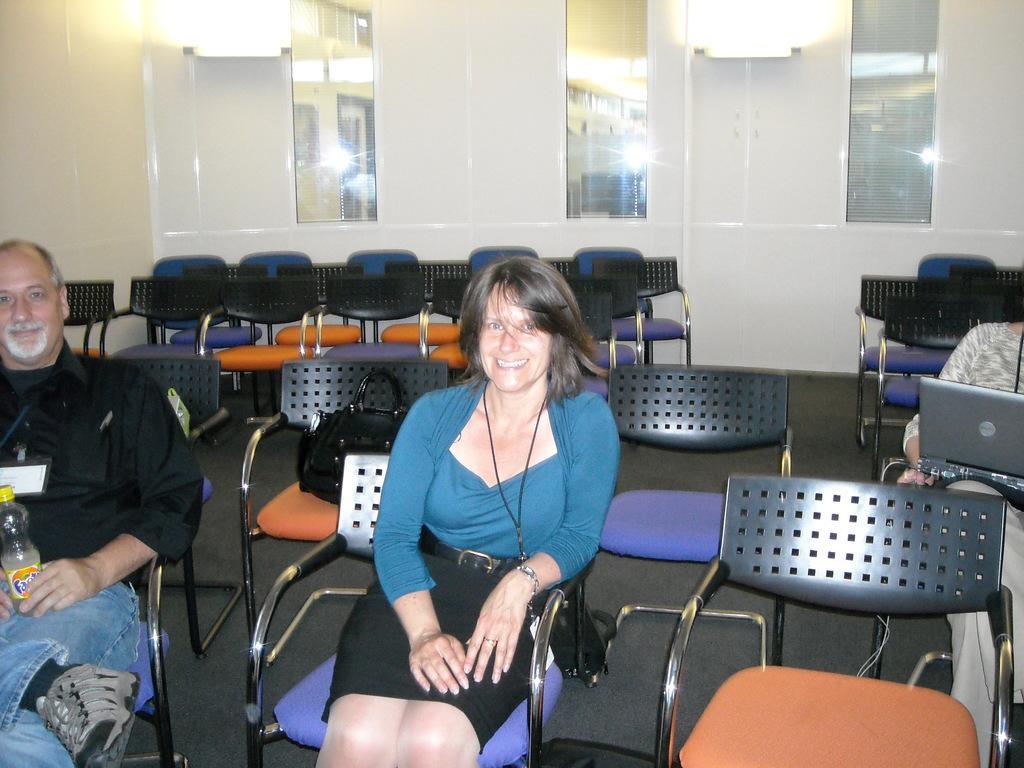How would you summarize this image in a sentence or two? In this image ,In the middle there is a woman she is smiling ,her hair is short. To the left ,there is a man he wear black shirt ,trouser and shoes. On the right there is a person. In the background there are many empty chairs ,light and mirror. 